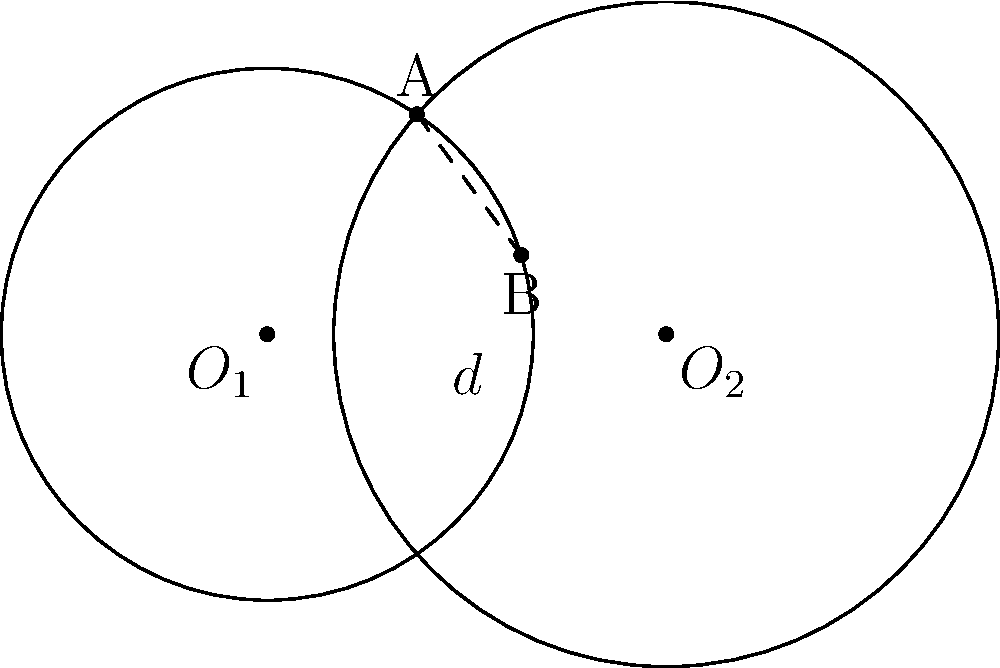Given two circles with centers $O_1$ and $O_2$, radii $r_1 = 2$ and $r_2 = 2.5$ respectively, and a distance $d = 3$ between their centers, derive an expression for the length of their common chord AB in terms of $r_1$, $r_2$, and $d$. How does this relate to the concept of power of a point with respect to a circle? Let's approach this step-by-step:

1) First, we need to recall the formula for the length of a common chord between two circles. If we denote the length of AB as $2h$, then:

   $$h^2 = \frac{(-d+r_1+r_2)(d+r_1-r_2)(d-r_1+r_2)(d+r_1+r_2)}{4d^2}$$

2) This formula is derived from the power of a point theorem. The power of a point with respect to a circle is constant for any line drawn through that point intersecting the circle.

3) In our case, we can substitute the given values:
   $r_1 = 2$, $r_2 = 2.5$, and $d = 3$

4) Plugging these into our formula:

   $$h^2 = \frac{(-3+2+2.5)(3+2-2.5)(3-2+2.5)(3+2+2.5)}{4(3^2)}$$

5) Simplifying:

   $$h^2 = \frac{(1.5)(2.5)(3.5)(7.5)}{36} = \frac{98.4375}{36} = 2.734375$$

6) Taking the square root and doubling (as $2h$ is the full length of AB):

   $AB = 2h = 2\sqrt{2.734375} \approx 3.3066$

7) The power of a point theorem states that for any point P and a circle with center O and radius r:

   $PA \cdot PB = PT^2 = PO^2 - r^2$

   where T is the point where a tangent from P touches the circle.

8) This concept is crucial in deriving the formula for the common chord length, as it establishes a relationship between the distances of intersection points and the relative positions of the circles.
Answer: $AB = 2\sqrt{\frac{(-d+r_1+r_2)(d+r_1-r_2)(d-r_1+r_2)(d+r_1+r_2)}{4d^2}}$ 